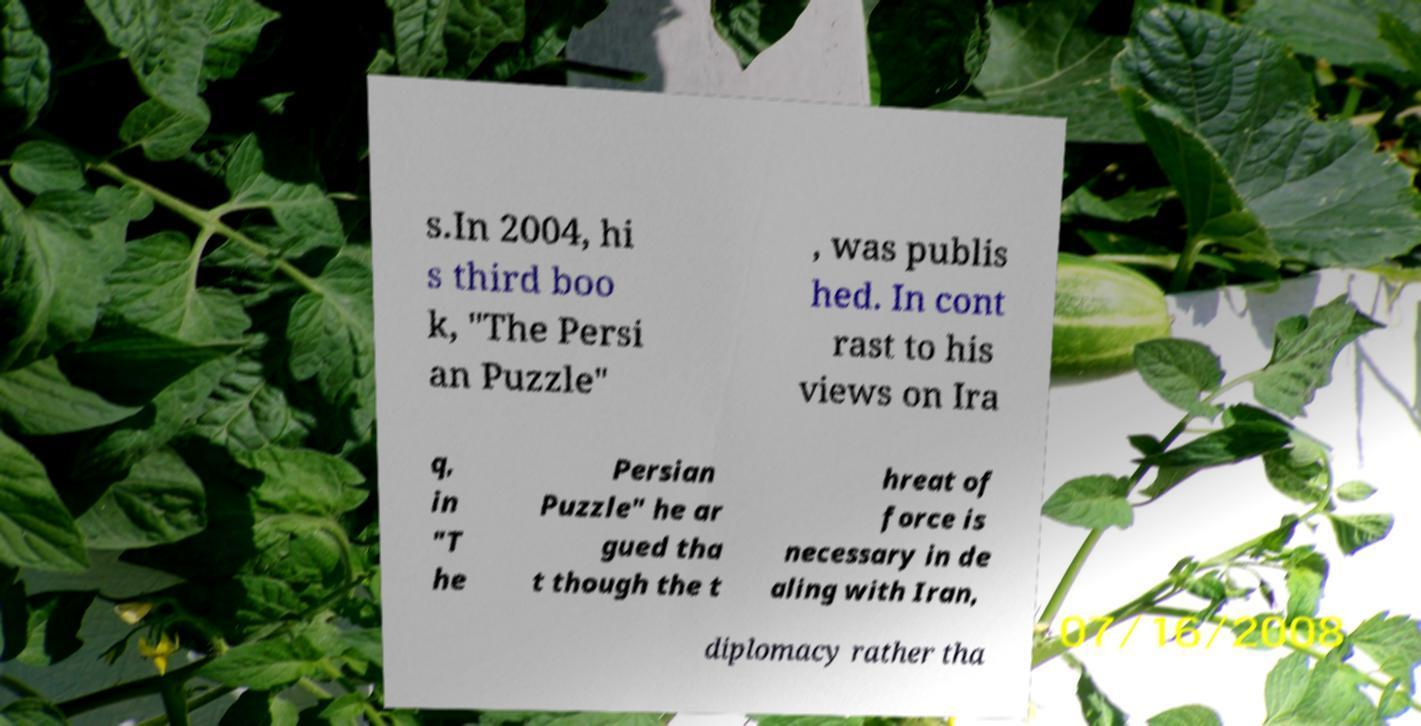For documentation purposes, I need the text within this image transcribed. Could you provide that? s.In 2004, hi s third boo k, "The Persi an Puzzle" , was publis hed. In cont rast to his views on Ira q, in "T he Persian Puzzle" he ar gued tha t though the t hreat of force is necessary in de aling with Iran, diplomacy rather tha 